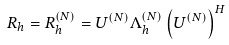<formula> <loc_0><loc_0><loc_500><loc_500>R _ { h } & = R _ { h } ^ { ( N ) } = U ^ { ( N ) } \Lambda _ { h } ^ { ( N ) } \left ( U ^ { ( N ) } \right ) ^ { H }</formula> 